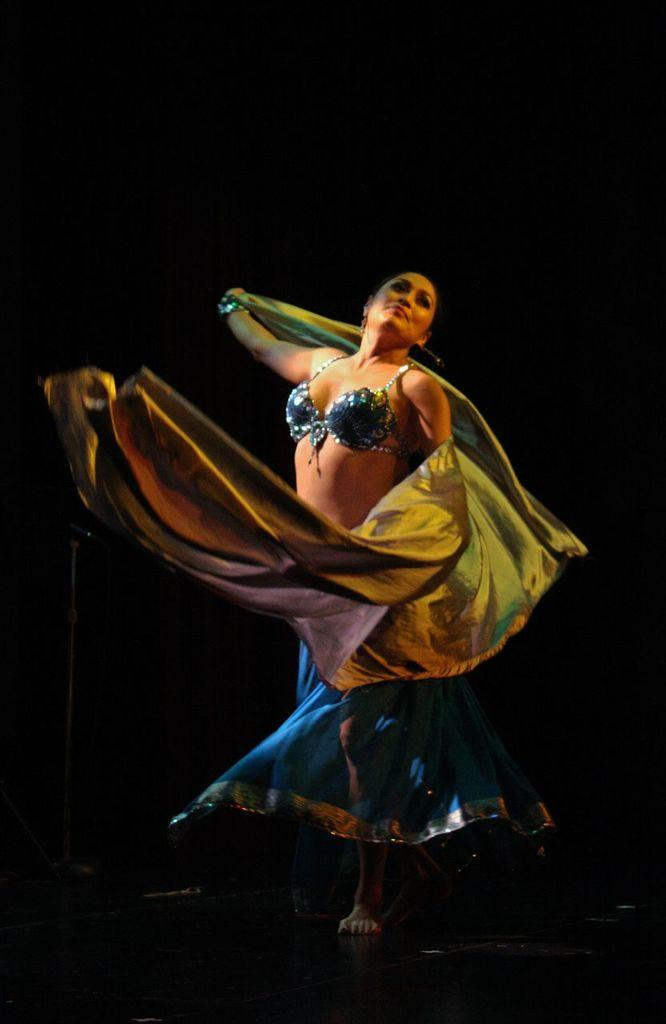What is the main subject in the foreground of the picture? There is a woman in the foreground of the picture. What is the woman doing in the image? The woman is dancing on the floor. What object is the woman holding in her hand? The woman is holding a cloth in her hand. How would you describe the background of the image? The background of the image is dark. Are there any plantations visible in the background of the image? There is no reference to a plantation in the image, so it cannot be determined if one is visible in the background. 